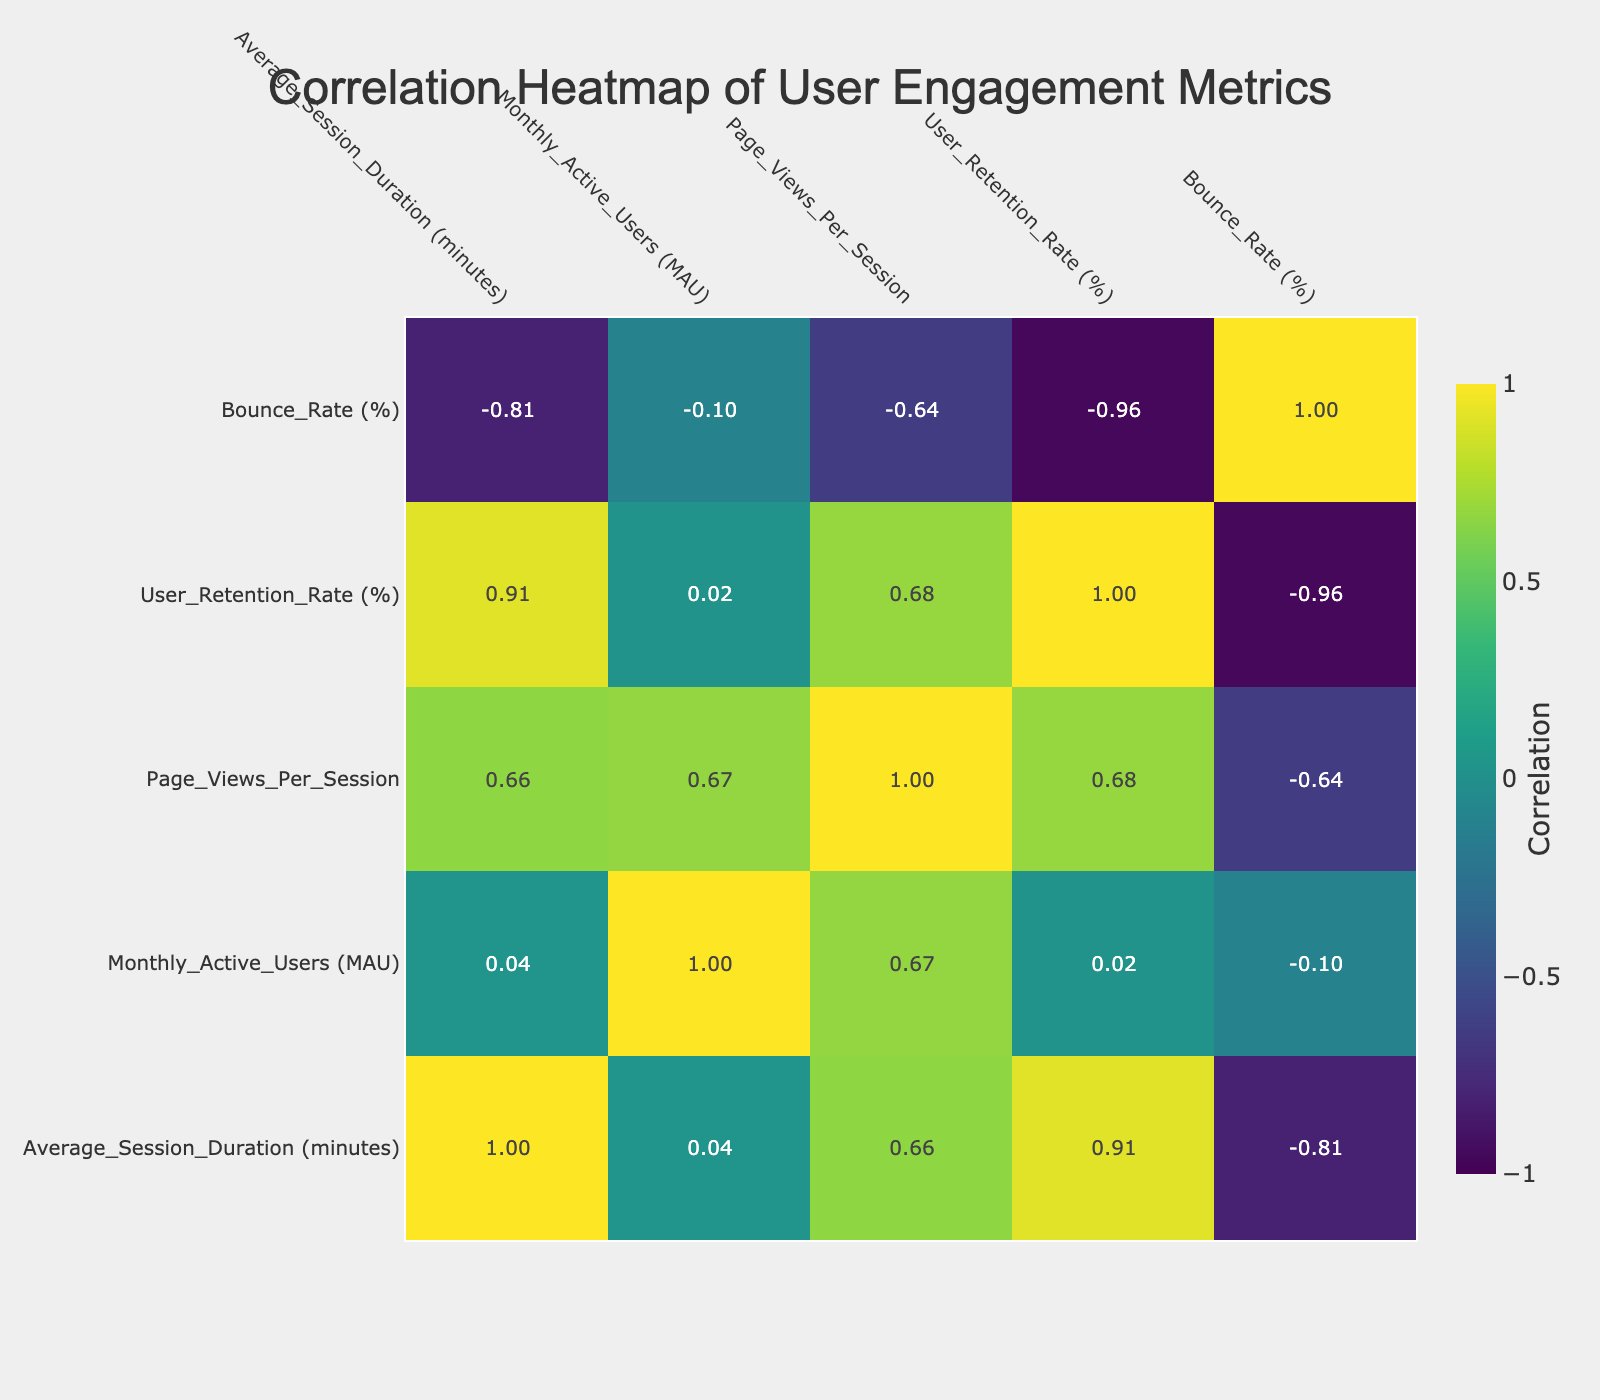What is the user retention rate for Social Network B? From the table, we can directly find the user retention rate for Social Network B in the respective column, which is listed as 75%.
Answer: 75% Which application has the highest average session duration? By comparing the values in the Average Session Duration column, Online Learning E has the highest value at 20.4 minutes.
Answer: 20.4 Calculate the average bounce rate across all applications. To calculate the average bounce rate, we add the bounce rates of all applications: (30 + 25 + 40 + 35 + 20 + 45 + 28 + 50 + 33 + 22) = 328. There are 10 applications, so the average bounce rate is 328/10 = 32.8%.
Answer: 32.8 Is the Monthly Active Users count for Travel Booking F greater than that for Real Estate H? Comparing the Monthly Active Users, Travel Booking F has 10,000 users while Real Estate H has 3,000. Thus, 10,000 is greater than 3,000.
Answer: Yes What is the correlation between Average Session Duration and User Retention Rate? To find the correlation, we look at the correlation table. The correlation value between Average Session Duration and User Retention Rate is approximately 0.77, indicating a strong positive relationship.
Answer: 0.77 Which application has the lowest Page Views Per Session? From the Page Views Per Session column, Real Estate H has the lowest value at 2.9.
Answer: 2.9 What is the difference in Monthly Active Users between Video Sharing D and Fitness Tracker J? Video Sharing D has 500,000 Monthly Active Users, and Fitness Tracker J has 60,000 MAUs. The difference is calculated as 500,000 - 60,000 = 440,000.
Answer: 440000 Is it true that Health App G has a higher average session duration than Job Search I? Health App G has an average session duration of 12.2 minutes and Job Search I has 8.4 minutes. Since 12.2 is greater than 8.4, the statement is true.
Answer: Yes What are the Monthly Active Users and Bounce Rate for Ecommerce Site A? In the table, Ecommerce Site A has 25,000 Monthly Active Users and a Bounce Rate of 30%.
Answer: 25,000 and 30% 